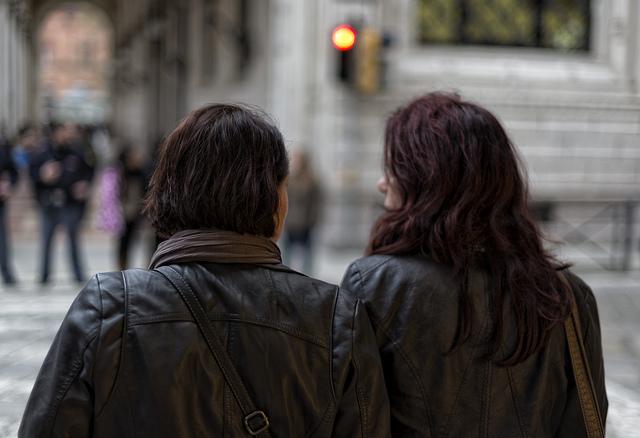What light on the stop light is lit?
Give a very brief answer. Red. What color are their coats?
Short answer required. Black. Is it night time?
Write a very short answer. No. 